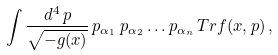Convert formula to latex. <formula><loc_0><loc_0><loc_500><loc_500>\int \frac { d ^ { 4 } \, p } { \sqrt { - { g } ( x ) } } \, p _ { \alpha _ { 1 } } \, p _ { \alpha _ { 2 } } \dots p _ { \alpha _ { n } } \, T r { f } ( x , p ) \, ,</formula> 